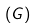<formula> <loc_0><loc_0><loc_500><loc_500>\left ( G \right )</formula> 